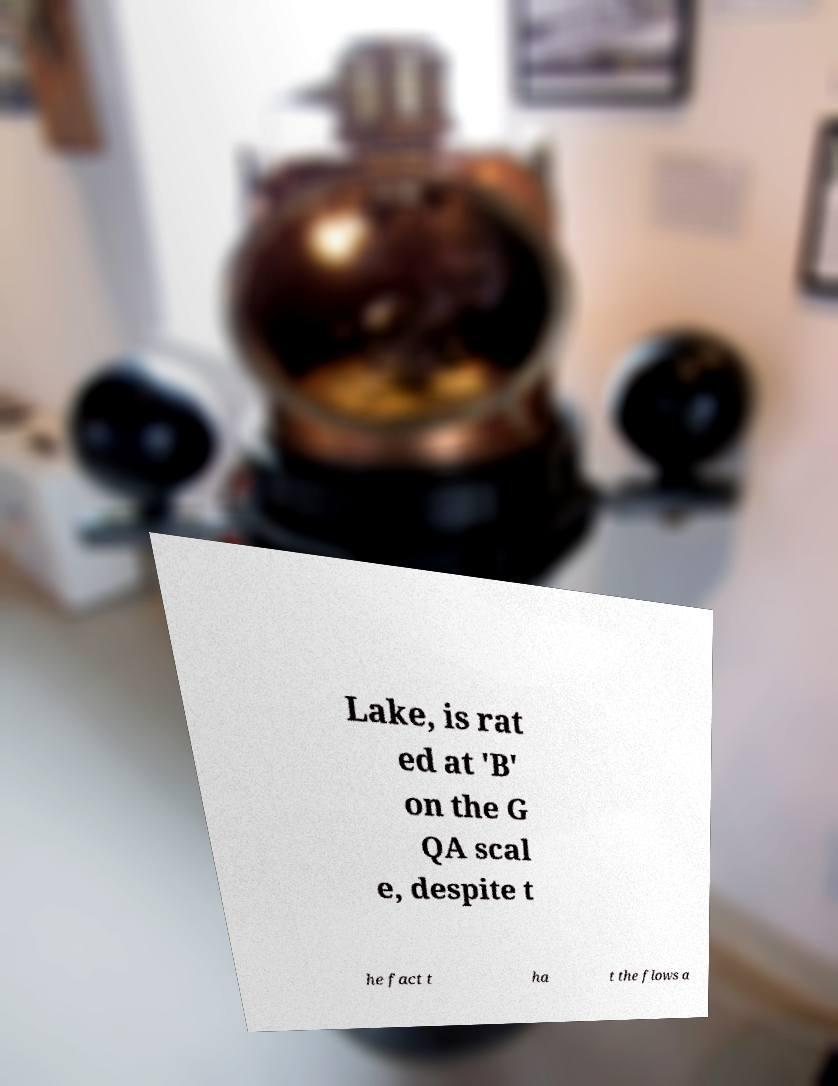Please identify and transcribe the text found in this image. Lake, is rat ed at 'B' on the G QA scal e, despite t he fact t ha t the flows a 